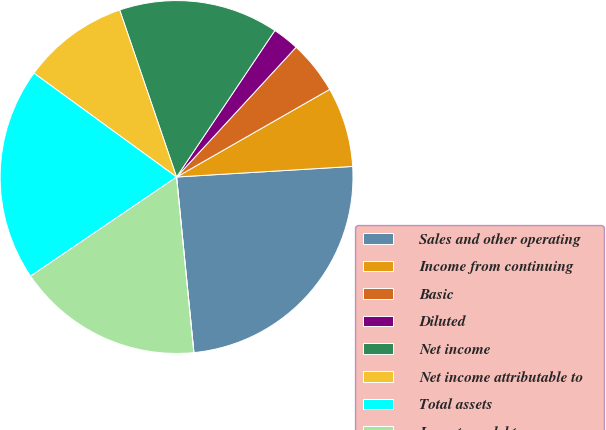<chart> <loc_0><loc_0><loc_500><loc_500><pie_chart><fcel>Sales and other operating<fcel>Income from continuing<fcel>Basic<fcel>Diluted<fcel>Net income<fcel>Net income attributable to<fcel>Total assets<fcel>Long-term debt<fcel>Cash dividends declared per<nl><fcel>24.39%<fcel>7.32%<fcel>4.88%<fcel>2.44%<fcel>14.63%<fcel>9.76%<fcel>19.51%<fcel>17.07%<fcel>0.0%<nl></chart> 